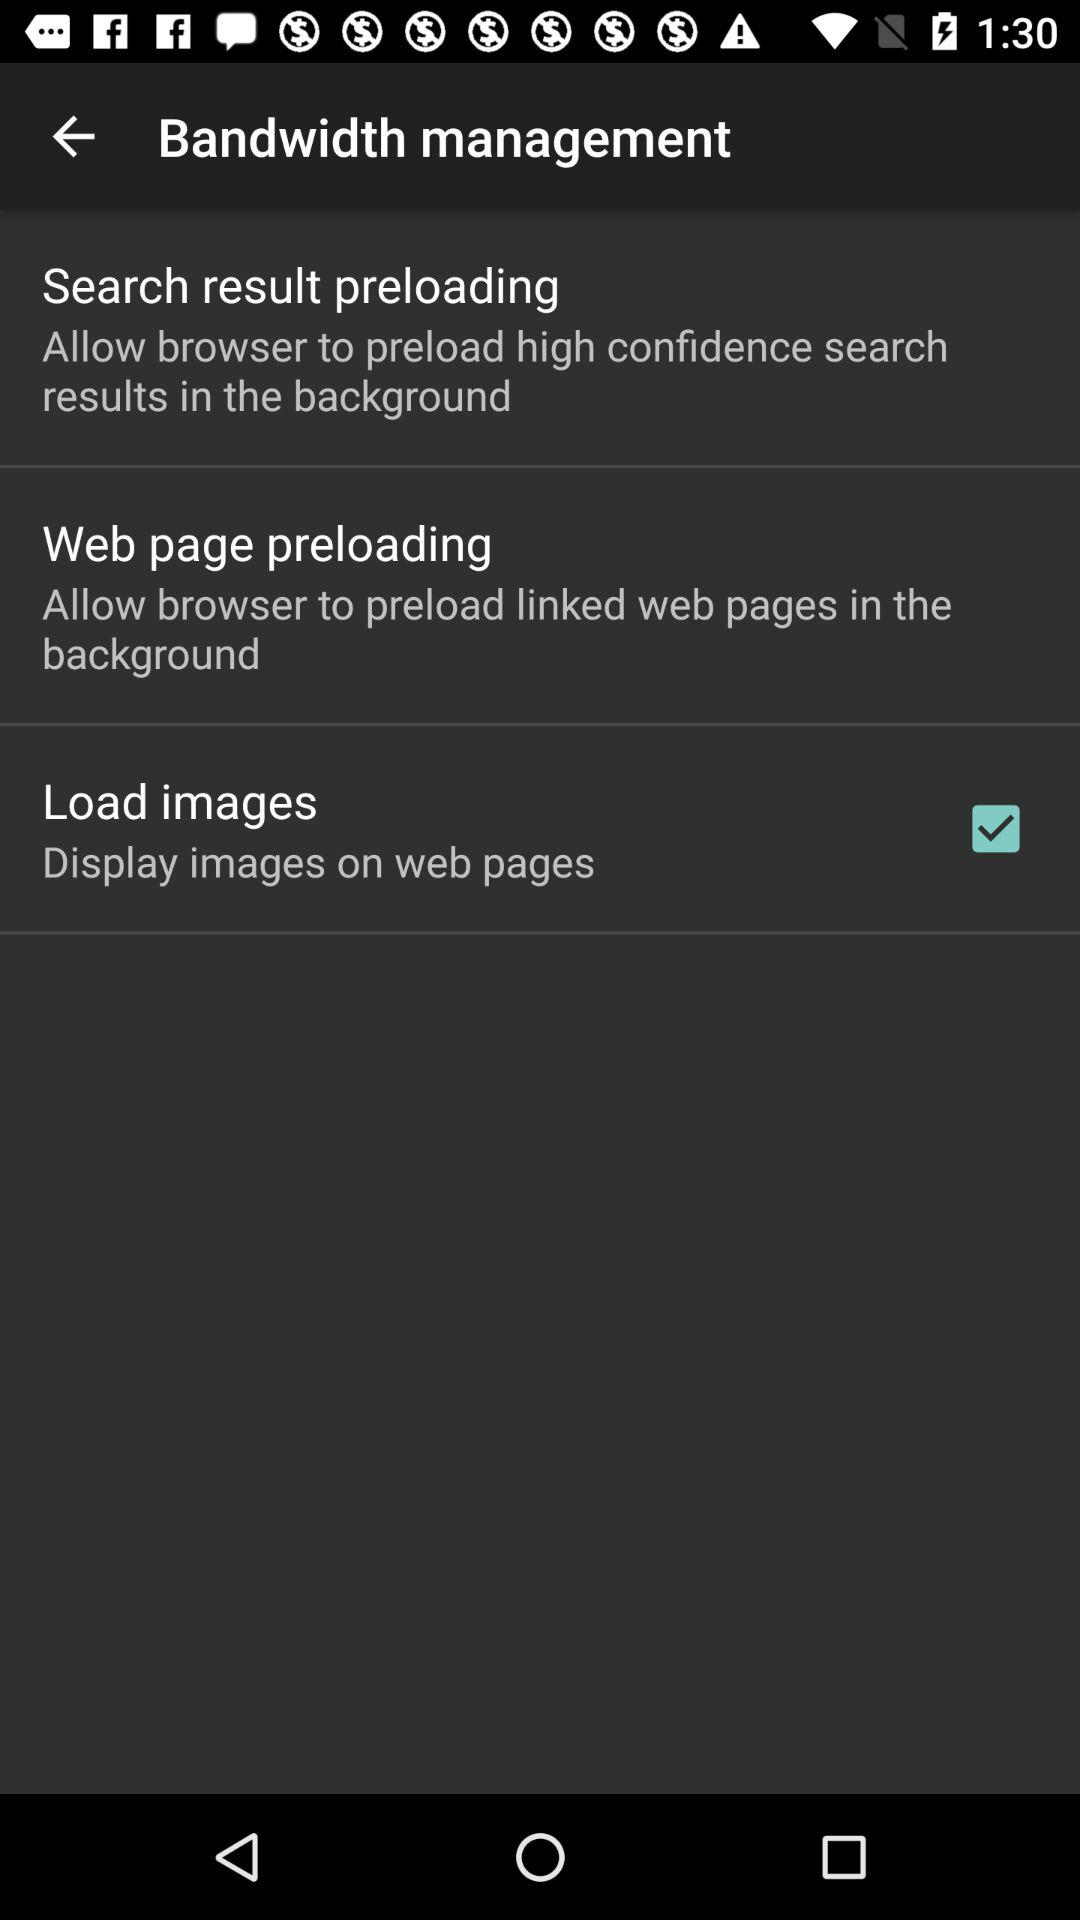How many of the three options allow the browser to preload content in the background?
Answer the question using a single word or phrase. 2 